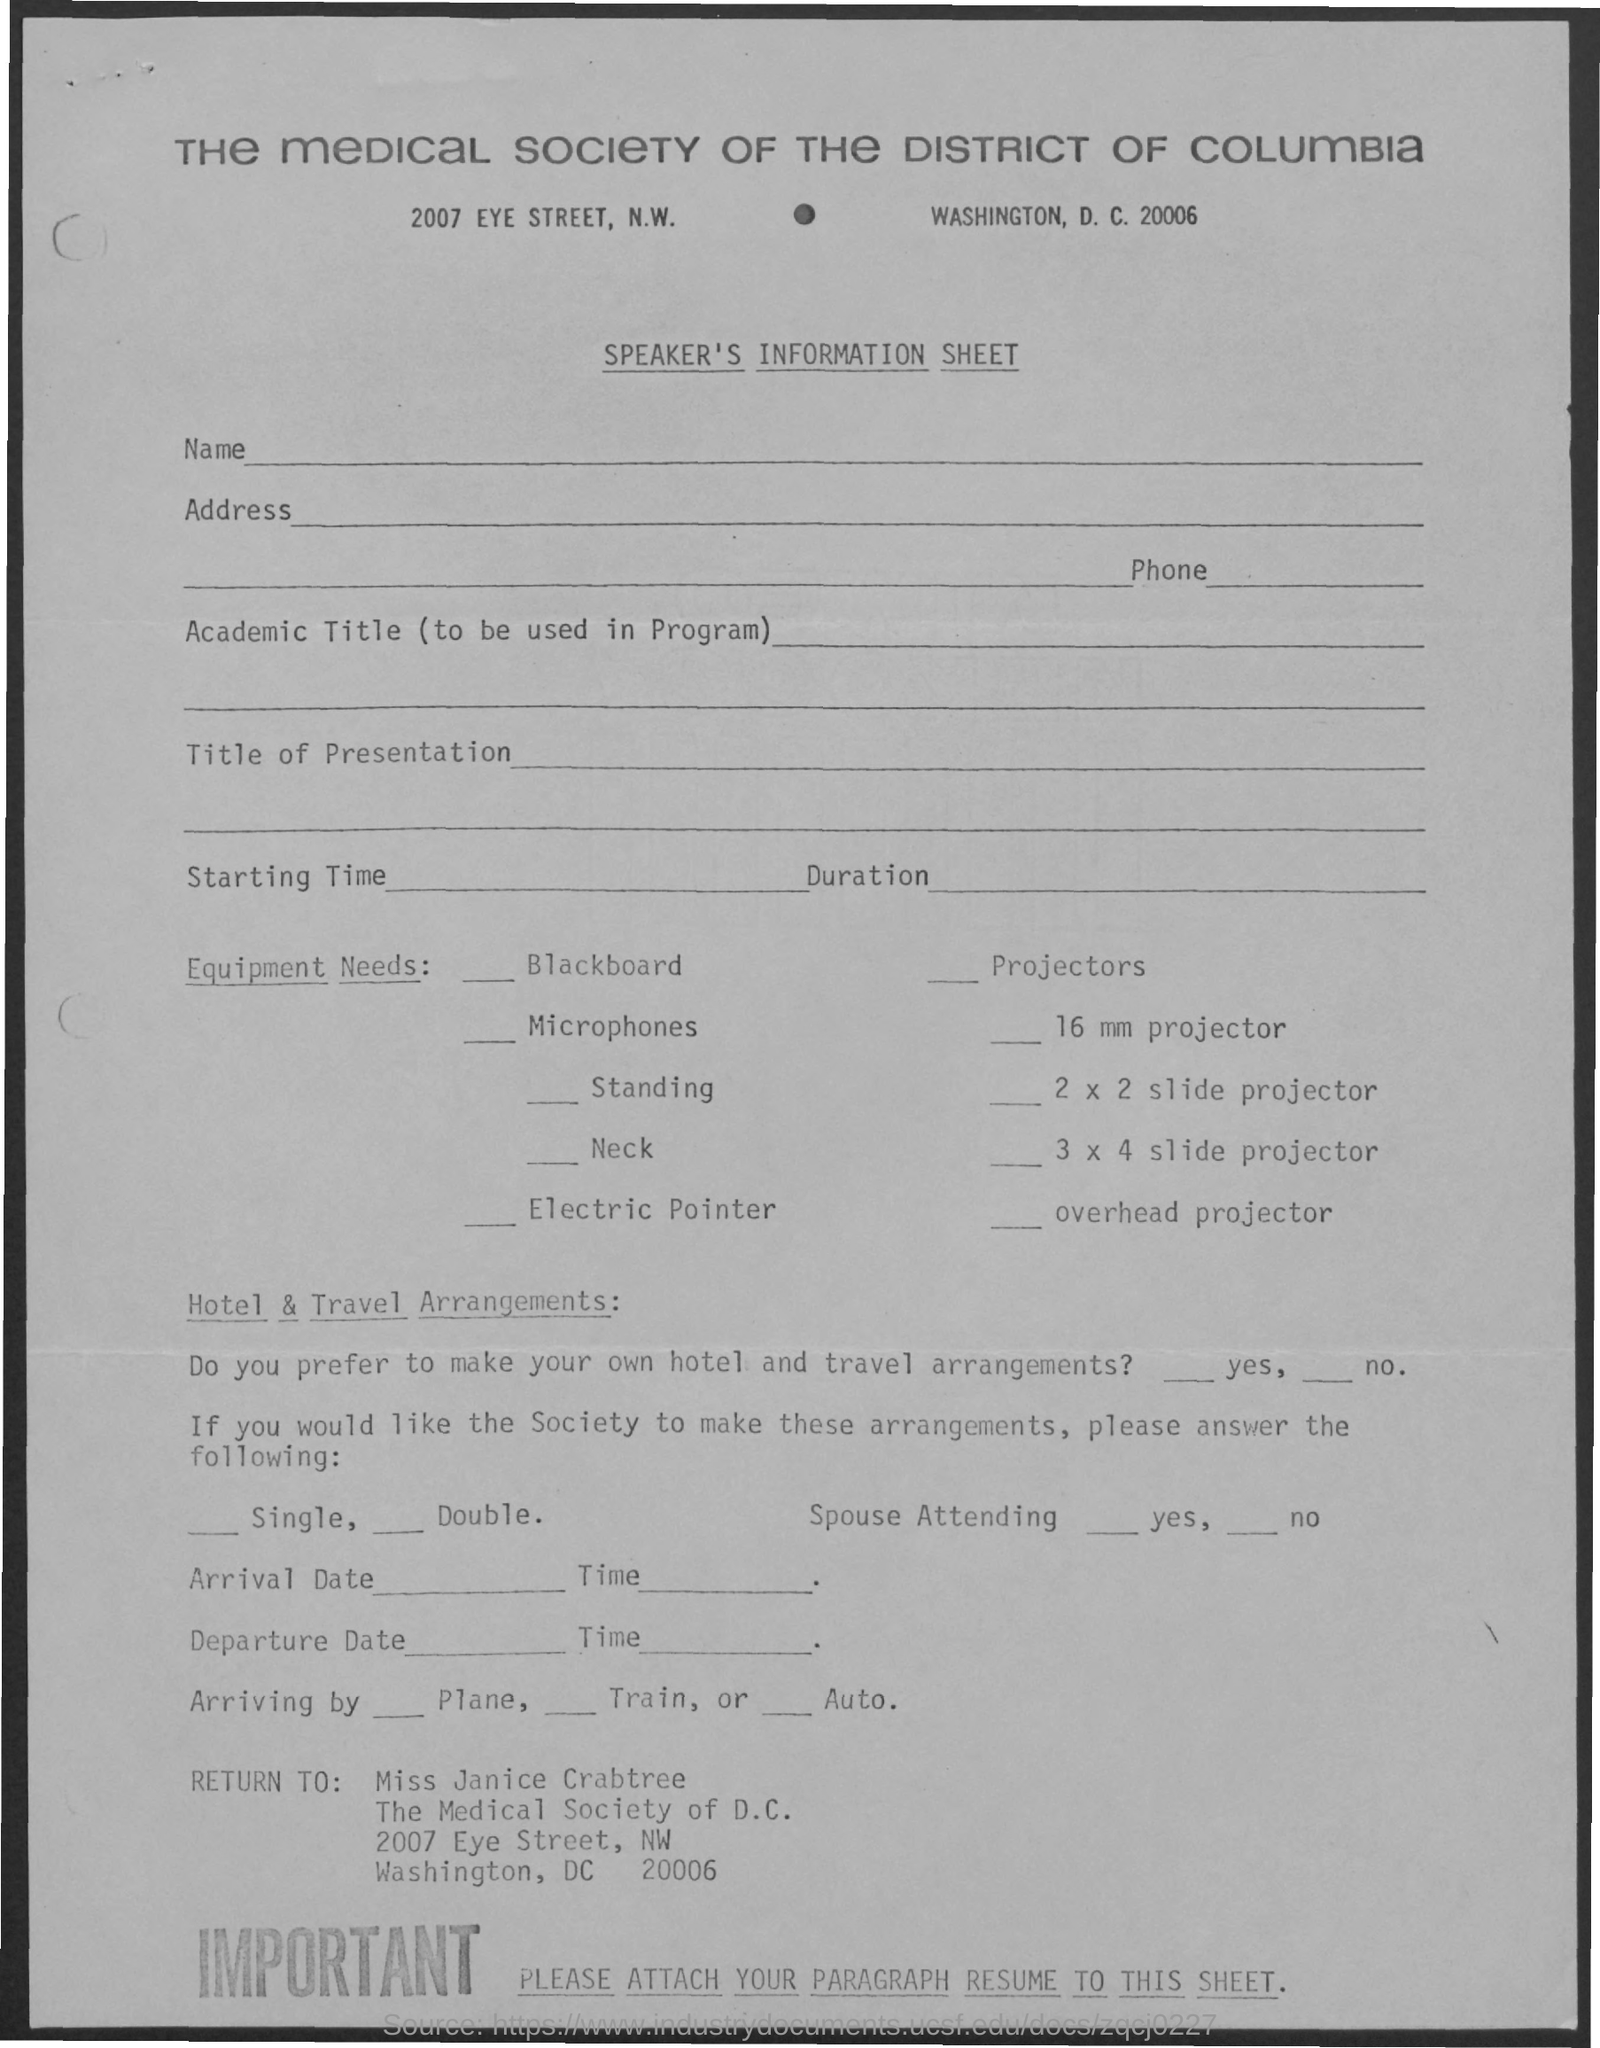Whose name is mentioned in the return to
Make the answer very short. Miss Janice Crabtree. 